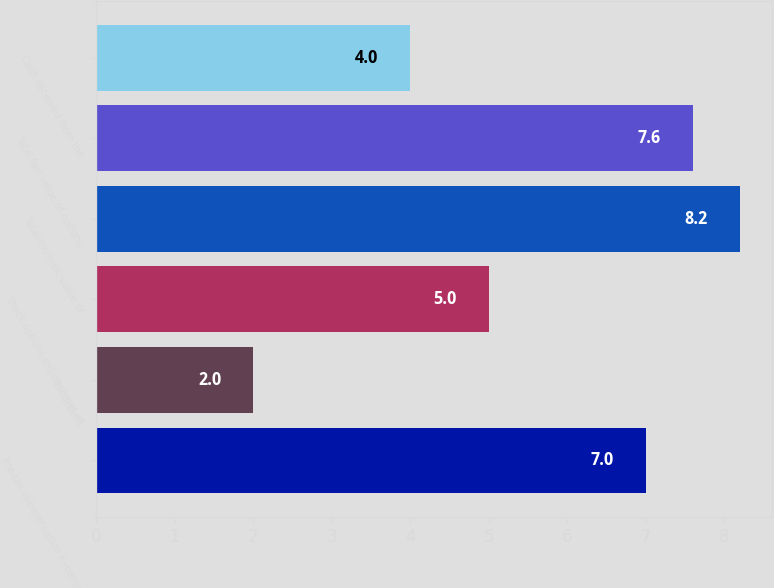<chart> <loc_0><loc_0><loc_500><loc_500><bar_chart><fcel>Pre-tax compensation expense<fcel>Tax benefit<fcel>Stock options expense net of<fcel>Total intrinsic value of<fcel>Total fair value of options<fcel>Cash received from the<nl><fcel>7<fcel>2<fcel>5<fcel>8.2<fcel>7.6<fcel>4<nl></chart> 